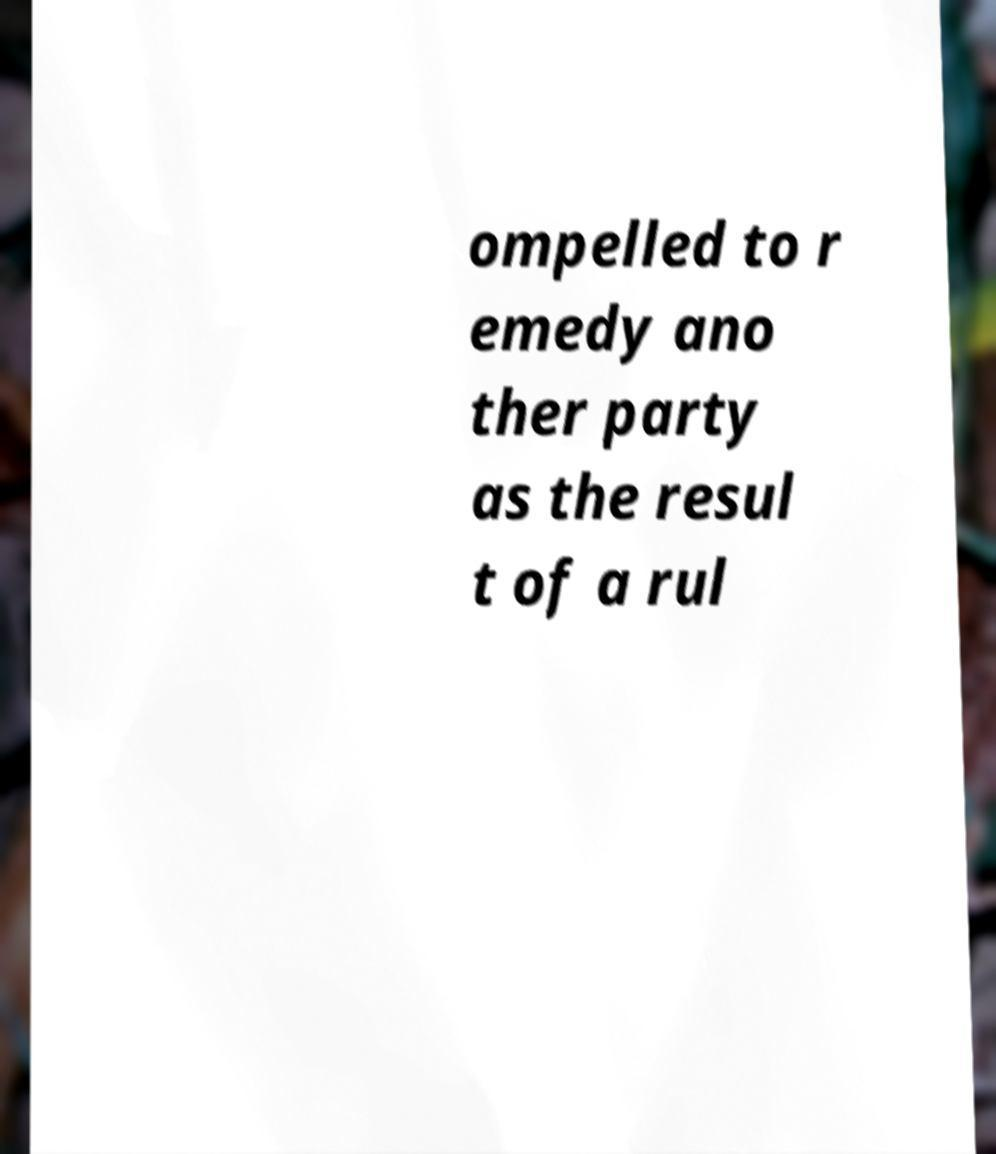For documentation purposes, I need the text within this image transcribed. Could you provide that? ompelled to r emedy ano ther party as the resul t of a rul 